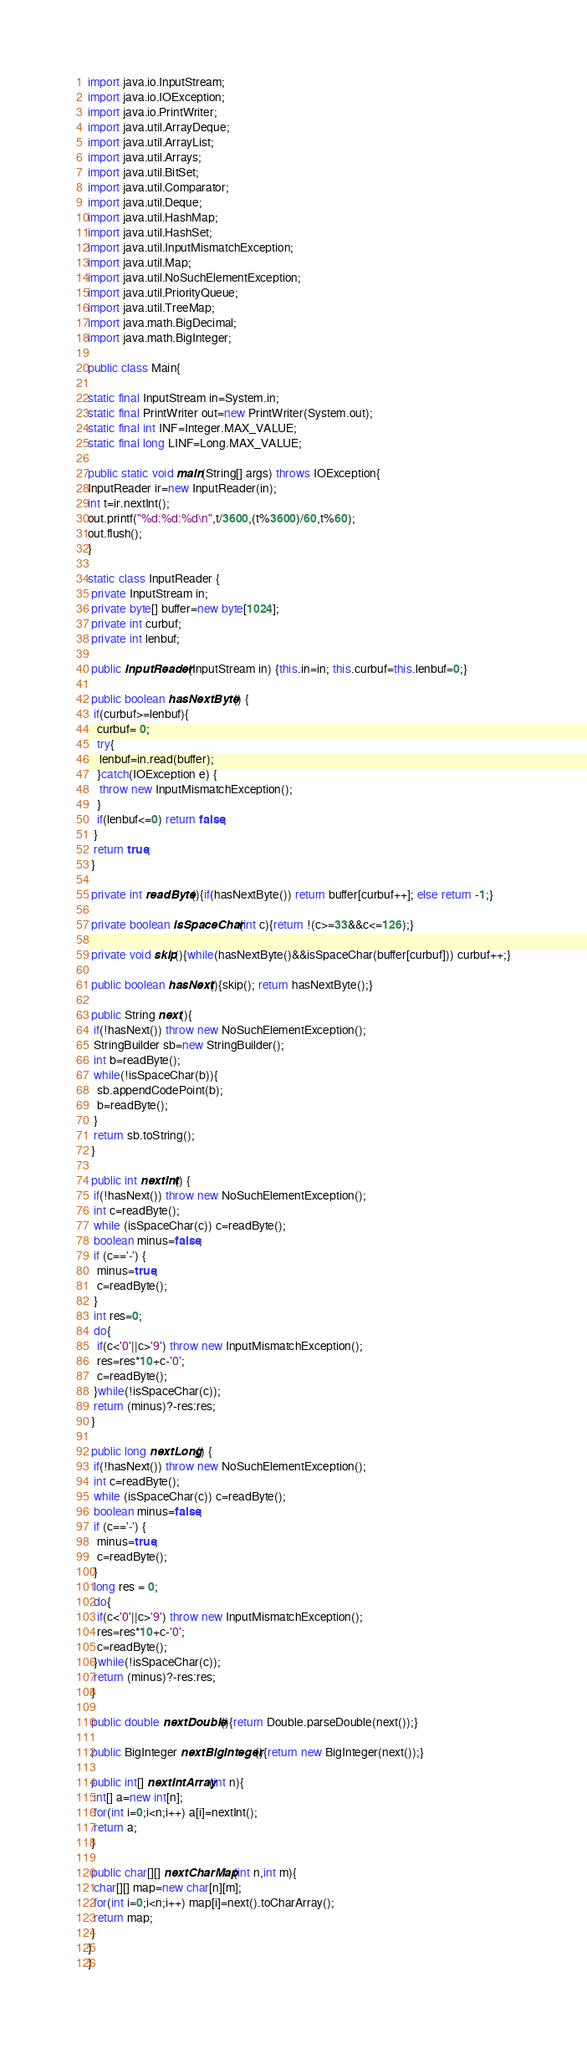Convert code to text. <code><loc_0><loc_0><loc_500><loc_500><_Java_>import java.io.InputStream;
import java.io.IOException;
import java.io.PrintWriter;
import java.util.ArrayDeque;
import java.util.ArrayList;
import java.util.Arrays;
import java.util.BitSet;
import java.util.Comparator;
import java.util.Deque;
import java.util.HashMap;
import java.util.HashSet;
import java.util.InputMismatchException;
import java.util.Map;
import java.util.NoSuchElementException;
import java.util.PriorityQueue;
import java.util.TreeMap;
import java.math.BigDecimal;
import java.math.BigInteger;
    
public class Main{
 
static final InputStream in=System.in;
static final PrintWriter out=new PrintWriter(System.out);
static final int INF=Integer.MAX_VALUE;
static final long LINF=Long.MAX_VALUE;
 
public static void main(String[] args) throws IOException{
InputReader ir=new InputReader(in);
int t=ir.nextInt();
out.printf("%d:%d:%d\n",t/3600,(t%3600)/60,t%60);
out.flush();
}

static class InputReader {
 private InputStream in;
 private byte[] buffer=new byte[1024];
 private int curbuf;
 private int lenbuf;
 
 public InputReader(InputStream in) {this.in=in; this.curbuf=this.lenbuf=0;}
  
 public boolean hasNextByte() {
  if(curbuf>=lenbuf){
   curbuf= 0;
   try{
    lenbuf=in.read(buffer);
   }catch(IOException e) {
    throw new InputMismatchException();
   }
   if(lenbuf<=0) return false;
  }
  return true;
 }
 
 private int readByte(){if(hasNextByte()) return buffer[curbuf++]; else return -1;}

 private boolean isSpaceChar(int c){return !(c>=33&&c<=126);}
 
 private void skip(){while(hasNextByte()&&isSpaceChar(buffer[curbuf])) curbuf++;}

 public boolean hasNext(){skip(); return hasNextByte();}
 
 public String next(){
  if(!hasNext()) throw new NoSuchElementException();
  StringBuilder sb=new StringBuilder();
  int b=readByte();
  while(!isSpaceChar(b)){
   sb.appendCodePoint(b);
   b=readByte();
  }
  return sb.toString();
 }
 
 public int nextInt() {
  if(!hasNext()) throw new NoSuchElementException();
  int c=readByte();
  while (isSpaceChar(c)) c=readByte();
  boolean minus=false;
  if (c=='-') {
   minus=true;
   c=readByte();
  }
  int res=0;
  do{
   if(c<'0'||c>'9') throw new InputMismatchException();
   res=res*10+c-'0';
   c=readByte();
  }while(!isSpaceChar(c));
  return (minus)?-res:res;
 }
 
 public long nextLong() {
  if(!hasNext()) throw new NoSuchElementException();
  int c=readByte();
  while (isSpaceChar(c)) c=readByte();
  boolean minus=false;
  if (c=='-') {
   minus=true;
   c=readByte();
  }
  long res = 0;
  do{
   if(c<'0'||c>'9') throw new InputMismatchException();
   res=res*10+c-'0';
   c=readByte();
  }while(!isSpaceChar(c));
  return (minus)?-res:res;
 }
 
 public double nextDouble(){return Double.parseDouble(next());}
 
 public BigInteger nextBigInteger(){return new BigInteger(next());}
 
 public int[] nextIntArray(int n){
  int[] a=new int[n];
  for(int i=0;i<n;i++) a[i]=nextInt();
  return a;
 }
 
 public char[][] nextCharMap(int n,int m){
  char[][] map=new char[n][m];
  for(int i=0;i<n;i++) map[i]=next().toCharArray();
  return map;
 }
}
}</code> 